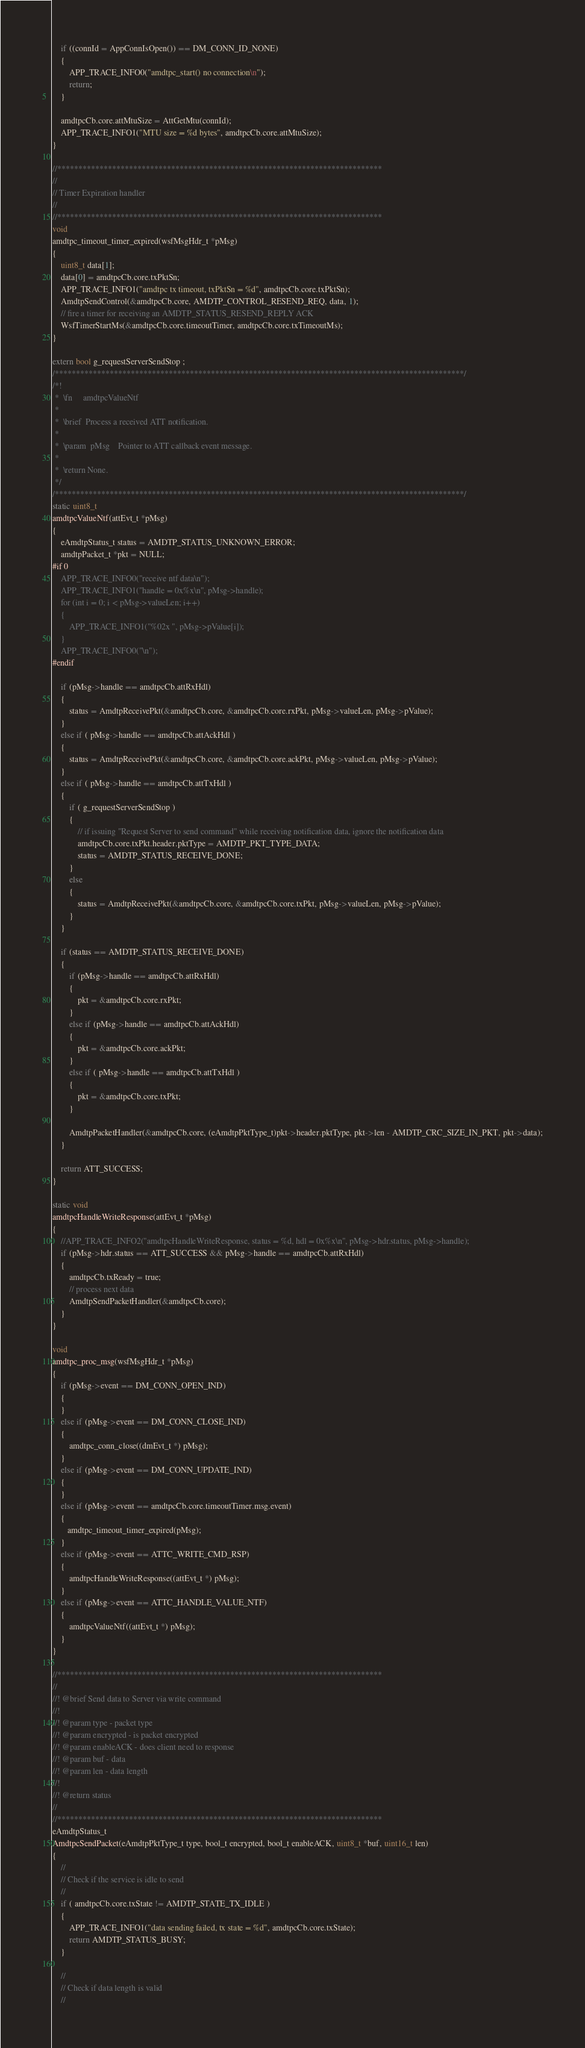<code> <loc_0><loc_0><loc_500><loc_500><_C_>    if ((connId = AppConnIsOpen()) == DM_CONN_ID_NONE)
    {
        APP_TRACE_INFO0("amdtpc_start() no connection\n");
        return;
    }

    amdtpcCb.core.attMtuSize = AttGetMtu(connId);
    APP_TRACE_INFO1("MTU size = %d bytes", amdtpcCb.core.attMtuSize);
}

//*****************************************************************************
//
// Timer Expiration handler
//
//*****************************************************************************
void
amdtpc_timeout_timer_expired(wsfMsgHdr_t *pMsg)
{
    uint8_t data[1];
    data[0] = amdtpcCb.core.txPktSn;
    APP_TRACE_INFO1("amdtpc tx timeout, txPktSn = %d", amdtpcCb.core.txPktSn);
    AmdtpSendControl(&amdtpcCb.core, AMDTP_CONTROL_RESEND_REQ, data, 1);
    // fire a timer for receiving an AMDTP_STATUS_RESEND_REPLY ACK
    WsfTimerStartMs(&amdtpcCb.core.timeoutTimer, amdtpcCb.core.txTimeoutMs);
}

extern bool g_requestServerSendStop ;
/*************************************************************************************************/
/*!
 *  \fn     amdtpcValueNtf
 *
 *  \brief  Process a received ATT notification.
 *
 *  \param  pMsg    Pointer to ATT callback event message.
 *
 *  \return None.
 */
/*************************************************************************************************/
static uint8_t
amdtpcValueNtf(attEvt_t *pMsg)
{
    eAmdtpStatus_t status = AMDTP_STATUS_UNKNOWN_ERROR;
    amdtpPacket_t *pkt = NULL;
#if 0
    APP_TRACE_INFO0("receive ntf data\n");
    APP_TRACE_INFO1("handle = 0x%x\n", pMsg->handle);
    for (int i = 0; i < pMsg->valueLen; i++)
    {
        APP_TRACE_INFO1("%02x ", pMsg->pValue[i]);
    }
    APP_TRACE_INFO0("\n");
#endif

    if (pMsg->handle == amdtpcCb.attRxHdl)
    {
        status = AmdtpReceivePkt(&amdtpcCb.core, &amdtpcCb.core.rxPkt, pMsg->valueLen, pMsg->pValue);
    }
    else if ( pMsg->handle == amdtpcCb.attAckHdl )
    {
        status = AmdtpReceivePkt(&amdtpcCb.core, &amdtpcCb.core.ackPkt, pMsg->valueLen, pMsg->pValue);
    }
    else if ( pMsg->handle == amdtpcCb.attTxHdl )
    {
        if ( g_requestServerSendStop )
        {
            // if issuing "Request Server to send command" while receiving notification data, ignore the notification data
            amdtpcCb.core.txPkt.header.pktType = AMDTP_PKT_TYPE_DATA;
            status = AMDTP_STATUS_RECEIVE_DONE;
        }
        else
        {
            status = AmdtpReceivePkt(&amdtpcCb.core, &amdtpcCb.core.txPkt, pMsg->valueLen, pMsg->pValue);
        }
    }

    if (status == AMDTP_STATUS_RECEIVE_DONE)
    {
        if (pMsg->handle == amdtpcCb.attRxHdl)
        {
            pkt = &amdtpcCb.core.rxPkt;
        }
        else if (pMsg->handle == amdtpcCb.attAckHdl)
        {
            pkt = &amdtpcCb.core.ackPkt;
        }
        else if ( pMsg->handle == amdtpcCb.attTxHdl )
        {
            pkt = &amdtpcCb.core.txPkt;
        }

        AmdtpPacketHandler(&amdtpcCb.core, (eAmdtpPktType_t)pkt->header.pktType, pkt->len - AMDTP_CRC_SIZE_IN_PKT, pkt->data);
    }

    return ATT_SUCCESS;
}

static void
amdtpcHandleWriteResponse(attEvt_t *pMsg)
{
    //APP_TRACE_INFO2("amdtpcHandleWriteResponse, status = %d, hdl = 0x%x\n", pMsg->hdr.status, pMsg->handle);
    if (pMsg->hdr.status == ATT_SUCCESS && pMsg->handle == amdtpcCb.attRxHdl)
    {
        amdtpcCb.txReady = true;
        // process next data
        AmdtpSendPacketHandler(&amdtpcCb.core);
    }
}

void
amdtpc_proc_msg(wsfMsgHdr_t *pMsg)
{
    if (pMsg->event == DM_CONN_OPEN_IND)
    {
    }
    else if (pMsg->event == DM_CONN_CLOSE_IND)
    {
        amdtpc_conn_close((dmEvt_t *) pMsg);
    }
    else if (pMsg->event == DM_CONN_UPDATE_IND)
    {
    }
    else if (pMsg->event == amdtpcCb.core.timeoutTimer.msg.event)
    {
       amdtpc_timeout_timer_expired(pMsg);
    }
    else if (pMsg->event == ATTC_WRITE_CMD_RSP)
    {
        amdtpcHandleWriteResponse((attEvt_t *) pMsg);
    }
    else if (pMsg->event == ATTC_HANDLE_VALUE_NTF)
    {
        amdtpcValueNtf((attEvt_t *) pMsg);
    }
}

//*****************************************************************************
//
//! @brief Send data to Server via write command
//!
//! @param type - packet type
//! @param encrypted - is packet encrypted
//! @param enableACK - does client need to response
//! @param buf - data
//! @param len - data length
//!
//! @return status
//
//*****************************************************************************
eAmdtpStatus_t
AmdtpcSendPacket(eAmdtpPktType_t type, bool_t encrypted, bool_t enableACK, uint8_t *buf, uint16_t len)
{
    //
    // Check if the service is idle to send
    //
    if ( amdtpcCb.core.txState != AMDTP_STATE_TX_IDLE )
    {
        APP_TRACE_INFO1("data sending failed, tx state = %d", amdtpcCb.core.txState);
        return AMDTP_STATUS_BUSY;
    }

    //
    // Check if data length is valid
    //</code> 